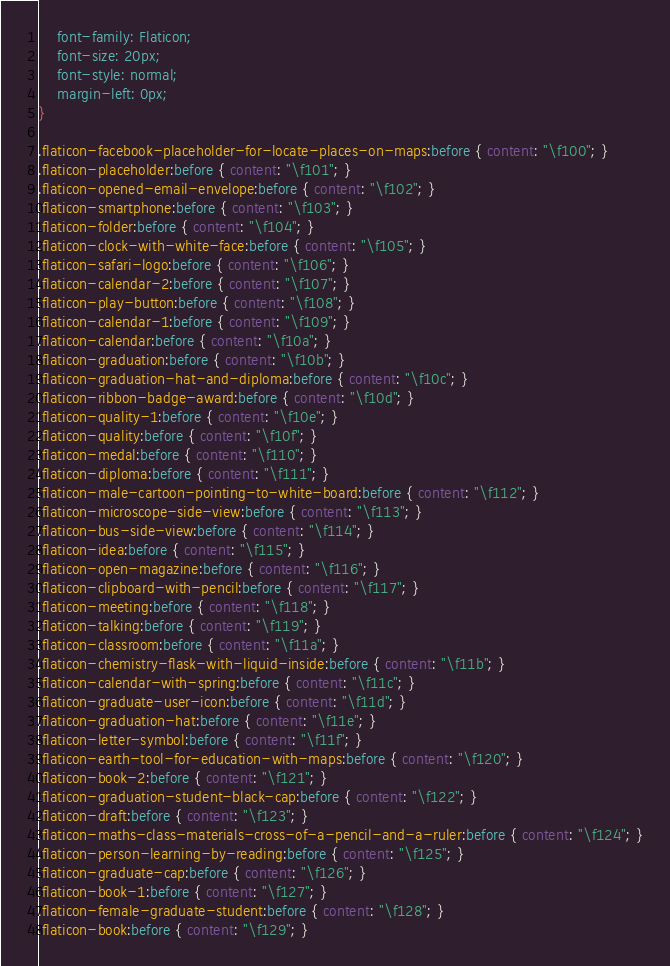Convert code to text. <code><loc_0><loc_0><loc_500><loc_500><_CSS_>	font-family: Flaticon;
	font-size: 20px;
	font-style: normal;
	margin-left: 0px;
}

.flaticon-facebook-placeholder-for-locate-places-on-maps:before { content: "\f100"; }
.flaticon-placeholder:before { content: "\f101"; }
.flaticon-opened-email-envelope:before { content: "\f102"; }
.flaticon-smartphone:before { content: "\f103"; }
.flaticon-folder:before { content: "\f104"; }
.flaticon-clock-with-white-face:before { content: "\f105"; }
.flaticon-safari-logo:before { content: "\f106"; }
.flaticon-calendar-2:before { content: "\f107"; }
.flaticon-play-button:before { content: "\f108"; }
.flaticon-calendar-1:before { content: "\f109"; }
.flaticon-calendar:before { content: "\f10a"; }
.flaticon-graduation:before { content: "\f10b"; }
.flaticon-graduation-hat-and-diploma:before { content: "\f10c"; }
.flaticon-ribbon-badge-award:before { content: "\f10d"; }
.flaticon-quality-1:before { content: "\f10e"; }
.flaticon-quality:before { content: "\f10f"; }
.flaticon-medal:before { content: "\f110"; }
.flaticon-diploma:before { content: "\f111"; }
.flaticon-male-cartoon-pointing-to-white-board:before { content: "\f112"; }
.flaticon-microscope-side-view:before { content: "\f113"; }
.flaticon-bus-side-view:before { content: "\f114"; }
.flaticon-idea:before { content: "\f115"; }
.flaticon-open-magazine:before { content: "\f116"; }
.flaticon-clipboard-with-pencil:before { content: "\f117"; }
.flaticon-meeting:before { content: "\f118"; }
.flaticon-talking:before { content: "\f119"; }
.flaticon-classroom:before { content: "\f11a"; }
.flaticon-chemistry-flask-with-liquid-inside:before { content: "\f11b"; }
.flaticon-calendar-with-spring:before { content: "\f11c"; }
.flaticon-graduate-user-icon:before { content: "\f11d"; }
.flaticon-graduation-hat:before { content: "\f11e"; }
.flaticon-letter-symbol:before { content: "\f11f"; }
.flaticon-earth-tool-for-education-with-maps:before { content: "\f120"; }
.flaticon-book-2:before { content: "\f121"; }
.flaticon-graduation-student-black-cap:before { content: "\f122"; }
.flaticon-draft:before { content: "\f123"; }
.flaticon-maths-class-materials-cross-of-a-pencil-and-a-ruler:before { content: "\f124"; }
.flaticon-person-learning-by-reading:before { content: "\f125"; }
.flaticon-graduate-cap:before { content: "\f126"; }
.flaticon-book-1:before { content: "\f127"; }
.flaticon-female-graduate-student:before { content: "\f128"; }
.flaticon-book:before { content: "\f129"; }</code> 